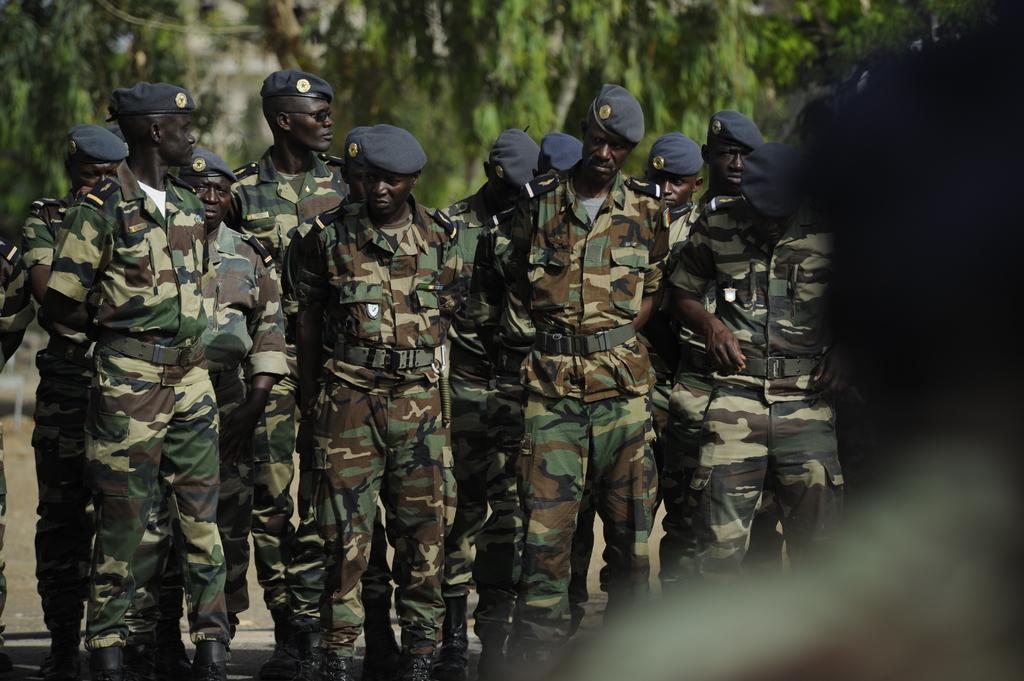How would you summarize this image in a sentence or two? In this image, we can see a group of people are standing. They are in military dress and wearing caps. Background we can see trees. Right side of the image, we can see a blur view. 